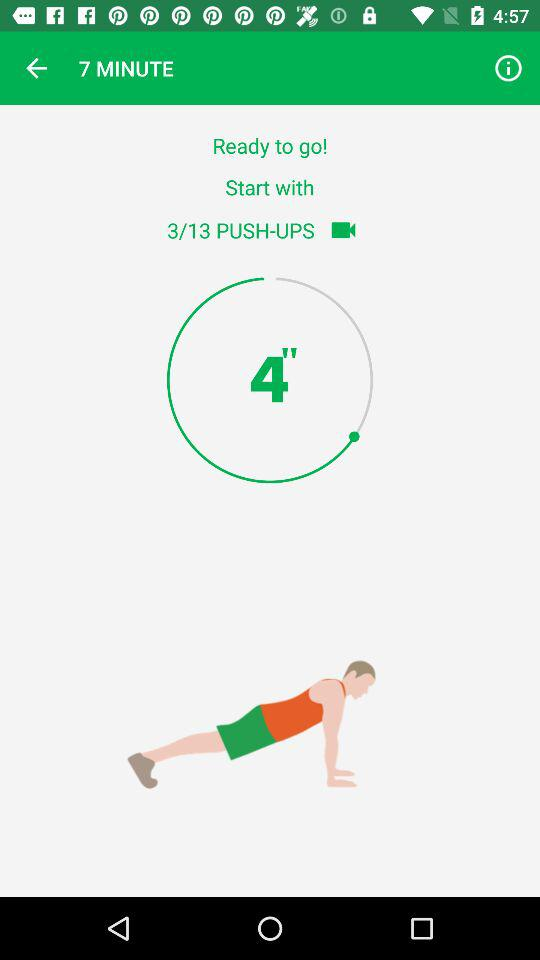How many minutes is the workout?
Answer the question using a single word or phrase. 7 